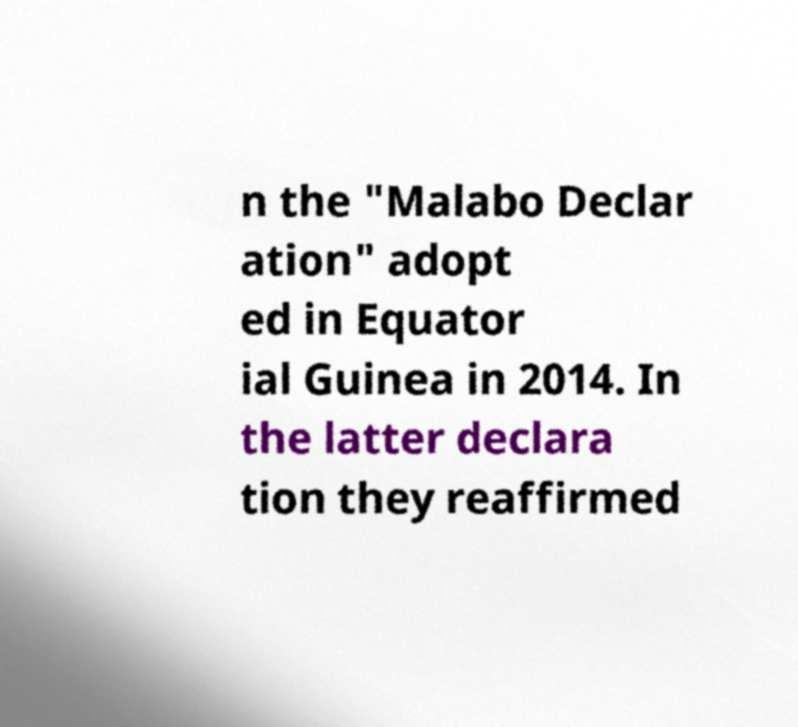Can you accurately transcribe the text from the provided image for me? n the "Malabo Declar ation" adopt ed in Equator ial Guinea in 2014. In the latter declara tion they reaffirmed 